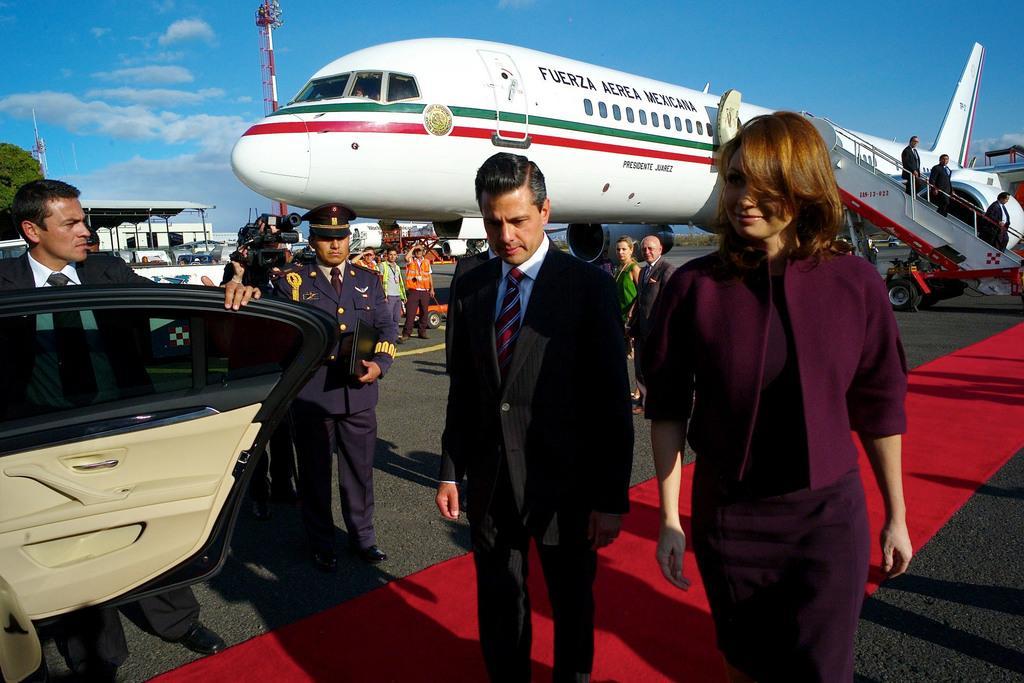Can you describe this image briefly? In this image we can see a group of people standing on the ground. In that three men are holding the door of a car, a laptop and a camera. On the backside we can see the airplanes and some people walking down stairs. We can also see a roof with some poles, a building, towers, a tree and the sky which looks cloudy. 